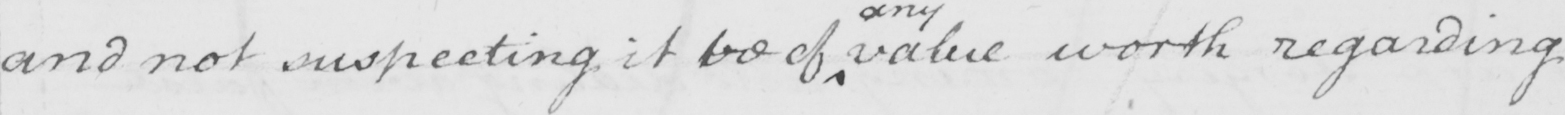What is written in this line of handwriting? and not suspecting it be of value worth regarding 